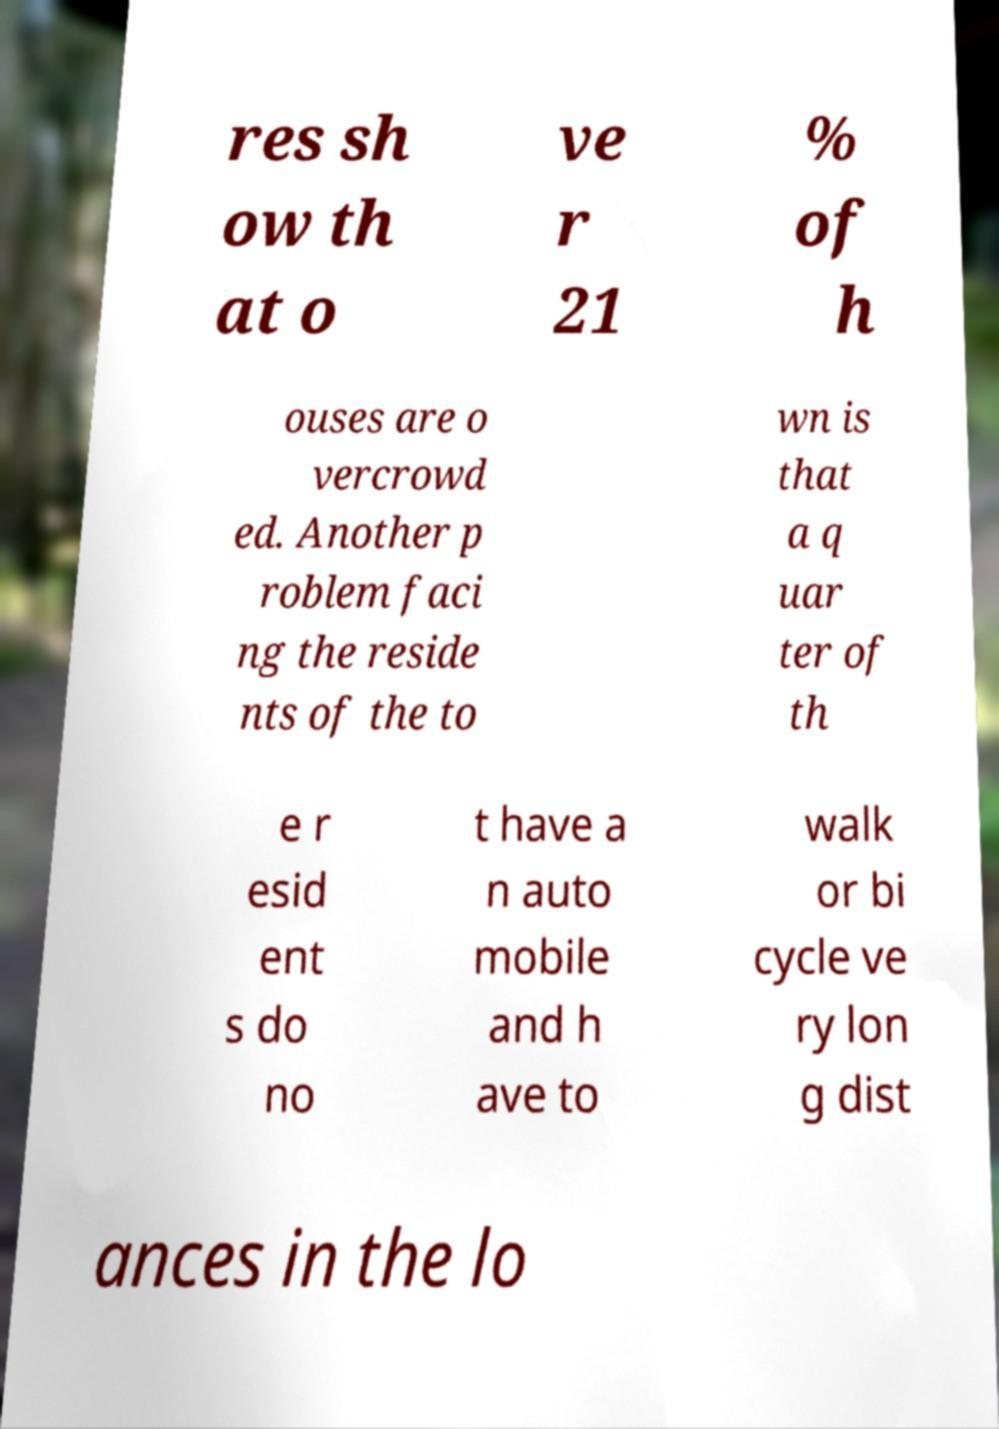I need the written content from this picture converted into text. Can you do that? res sh ow th at o ve r 21 % of h ouses are o vercrowd ed. Another p roblem faci ng the reside nts of the to wn is that a q uar ter of th e r esid ent s do no t have a n auto mobile and h ave to walk or bi cycle ve ry lon g dist ances in the lo 